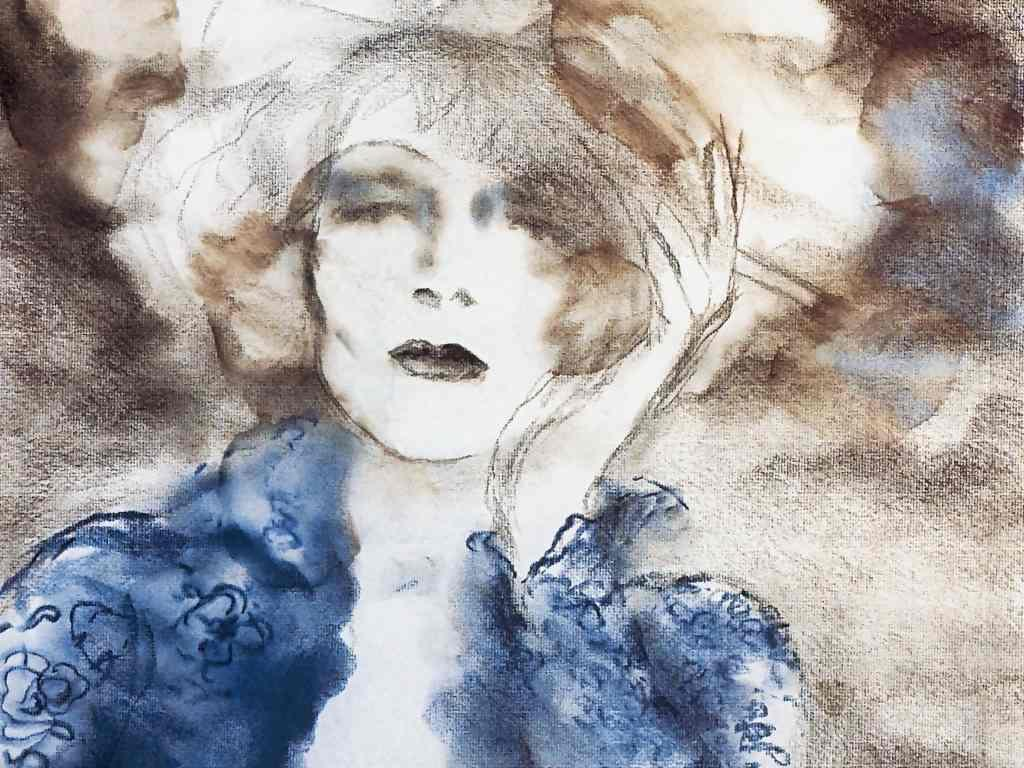What is depicted in the image? There is a sketch of a lady in the image. What type of bead is used to create the alarm in the image? There is no bead or alarm present in the image; it only features a sketch of a lady. 